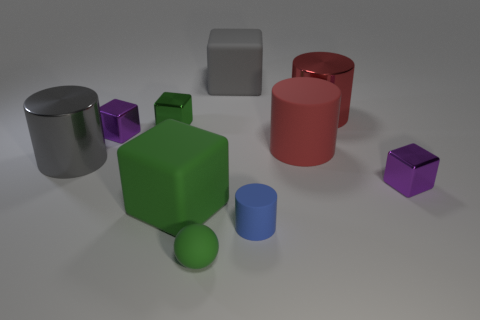There is a large red thing that is in front of the green metal object; what shape is it? cylinder 